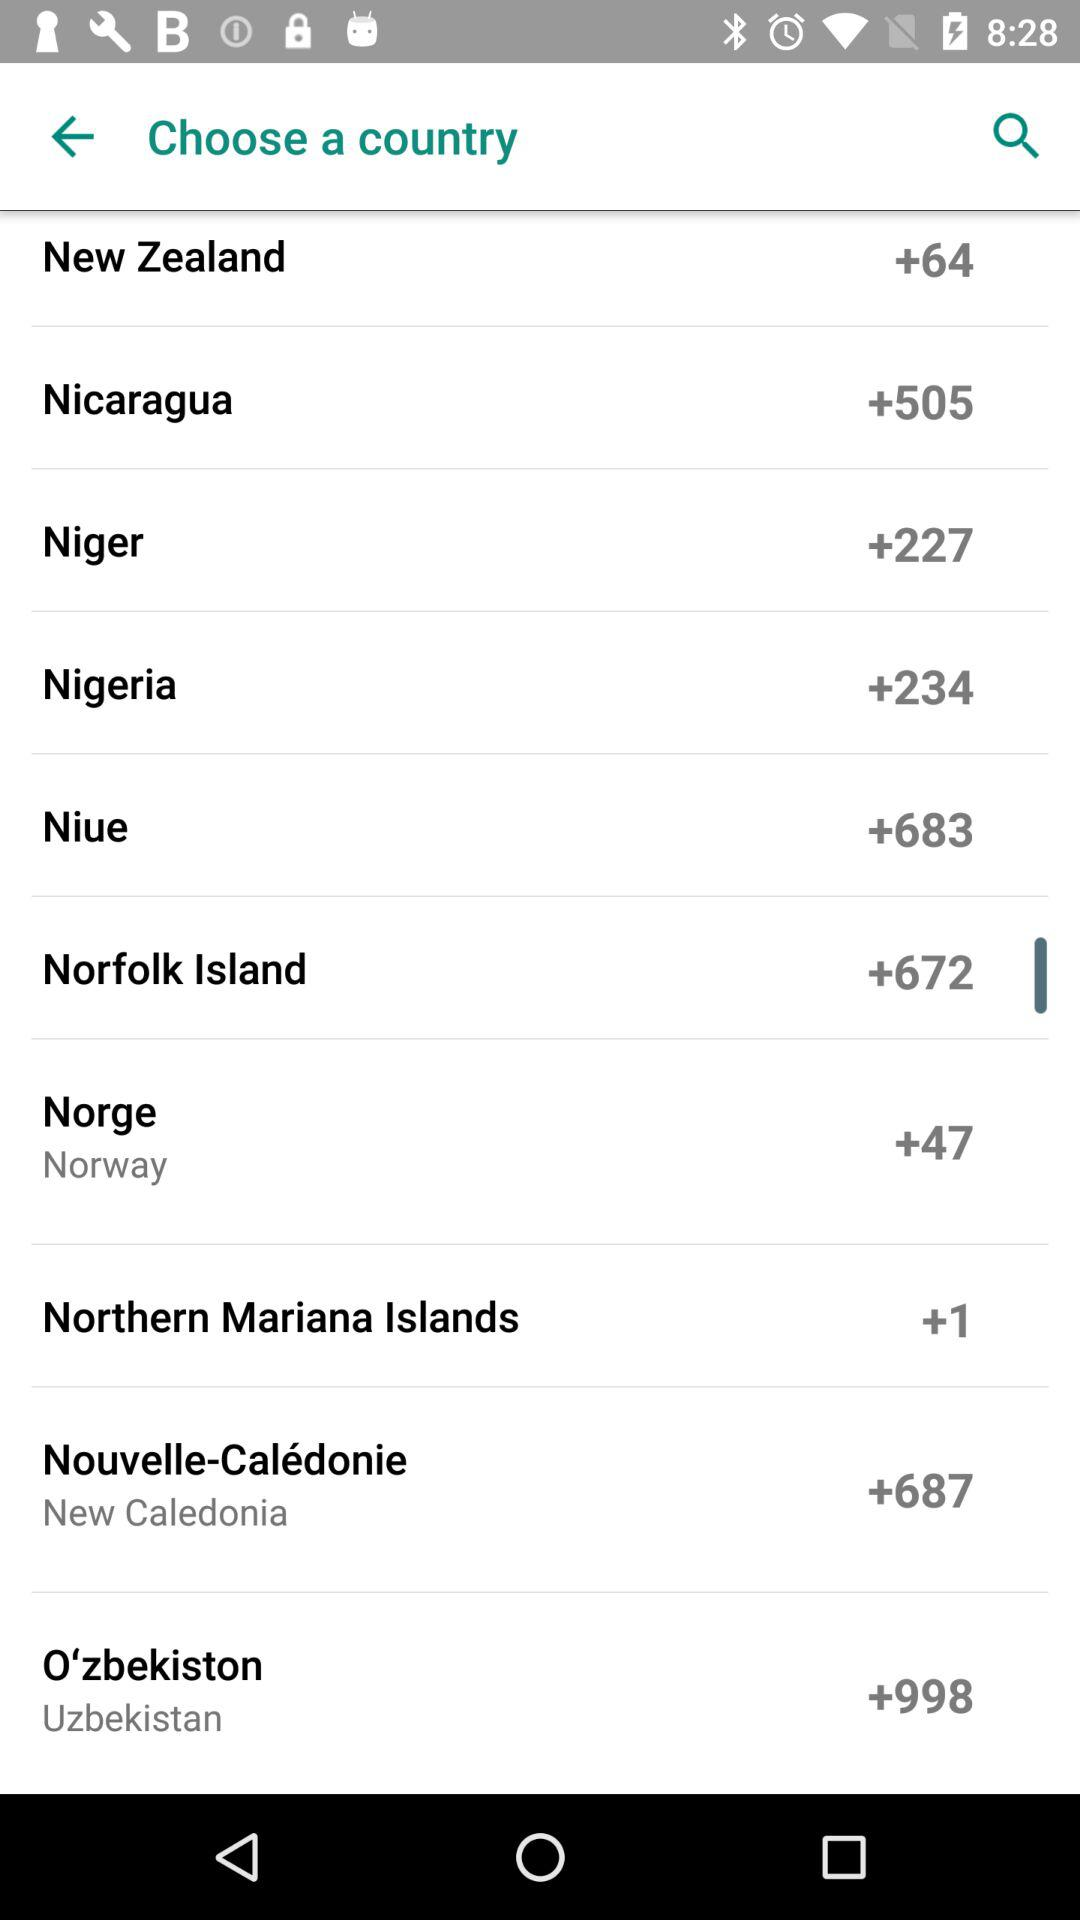What is the country code for New Zealand? The country code for New Zealand is +64. 